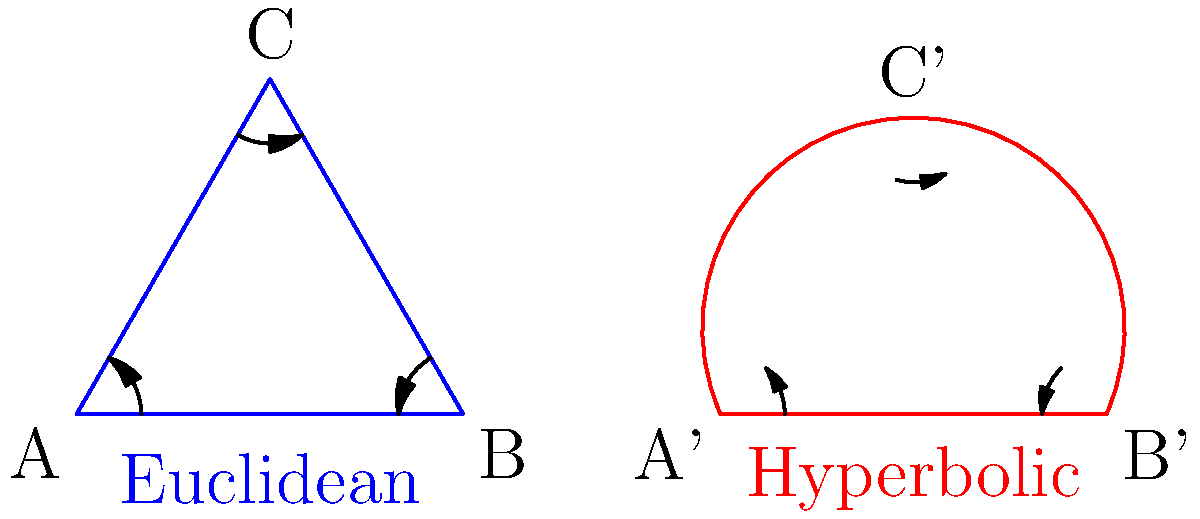In the diagram, two triangles are shown: one in Euclidean geometry (blue) and one in hyperbolic geometry (red). If the sum of the interior angles in the Euclidean triangle is 180°, what is the approximate sum of the interior angles in the hyperbolic triangle? To answer this question, let's break it down step-by-step:

1. In Euclidean geometry, the sum of the interior angles of any triangle is always 180°. This is represented by the blue triangle in the diagram.

2. In hyperbolic geometry, the rules are different. The sum of the interior angles of a triangle is always less than 180°.

3. Looking at the red hyperbolic triangle in the diagram, we can observe that:
   a) The angles appear to be smaller than those in the Euclidean triangle.
   b) The sides of the triangle are curved inward, which is characteristic of hyperbolic geometry.

4. In hyperbolic geometry, the sum of the interior angles of a triangle depends on the area of the triangle. The larger the area, the smaller the sum of the angles.

5. While we can't determine the exact sum without more information, we can estimate that the sum of the angles in the hyperbolic triangle is approximately 150° to 170°.

6. This range is chosen because:
   a) It's noticeably less than 180°, reflecting the fundamental property of hyperbolic triangles.
   b) It's not too small, as the triangle doesn't appear to be extremely large in the hyperbolic plane.

Therefore, based on the visual representation and the principles of hyperbolic geometry, we can conclude that the sum of the interior angles in the hyperbolic triangle is less than 180° and approximately in the range of 150° to 170°.
Answer: Less than 180°, approximately 150°-170° 